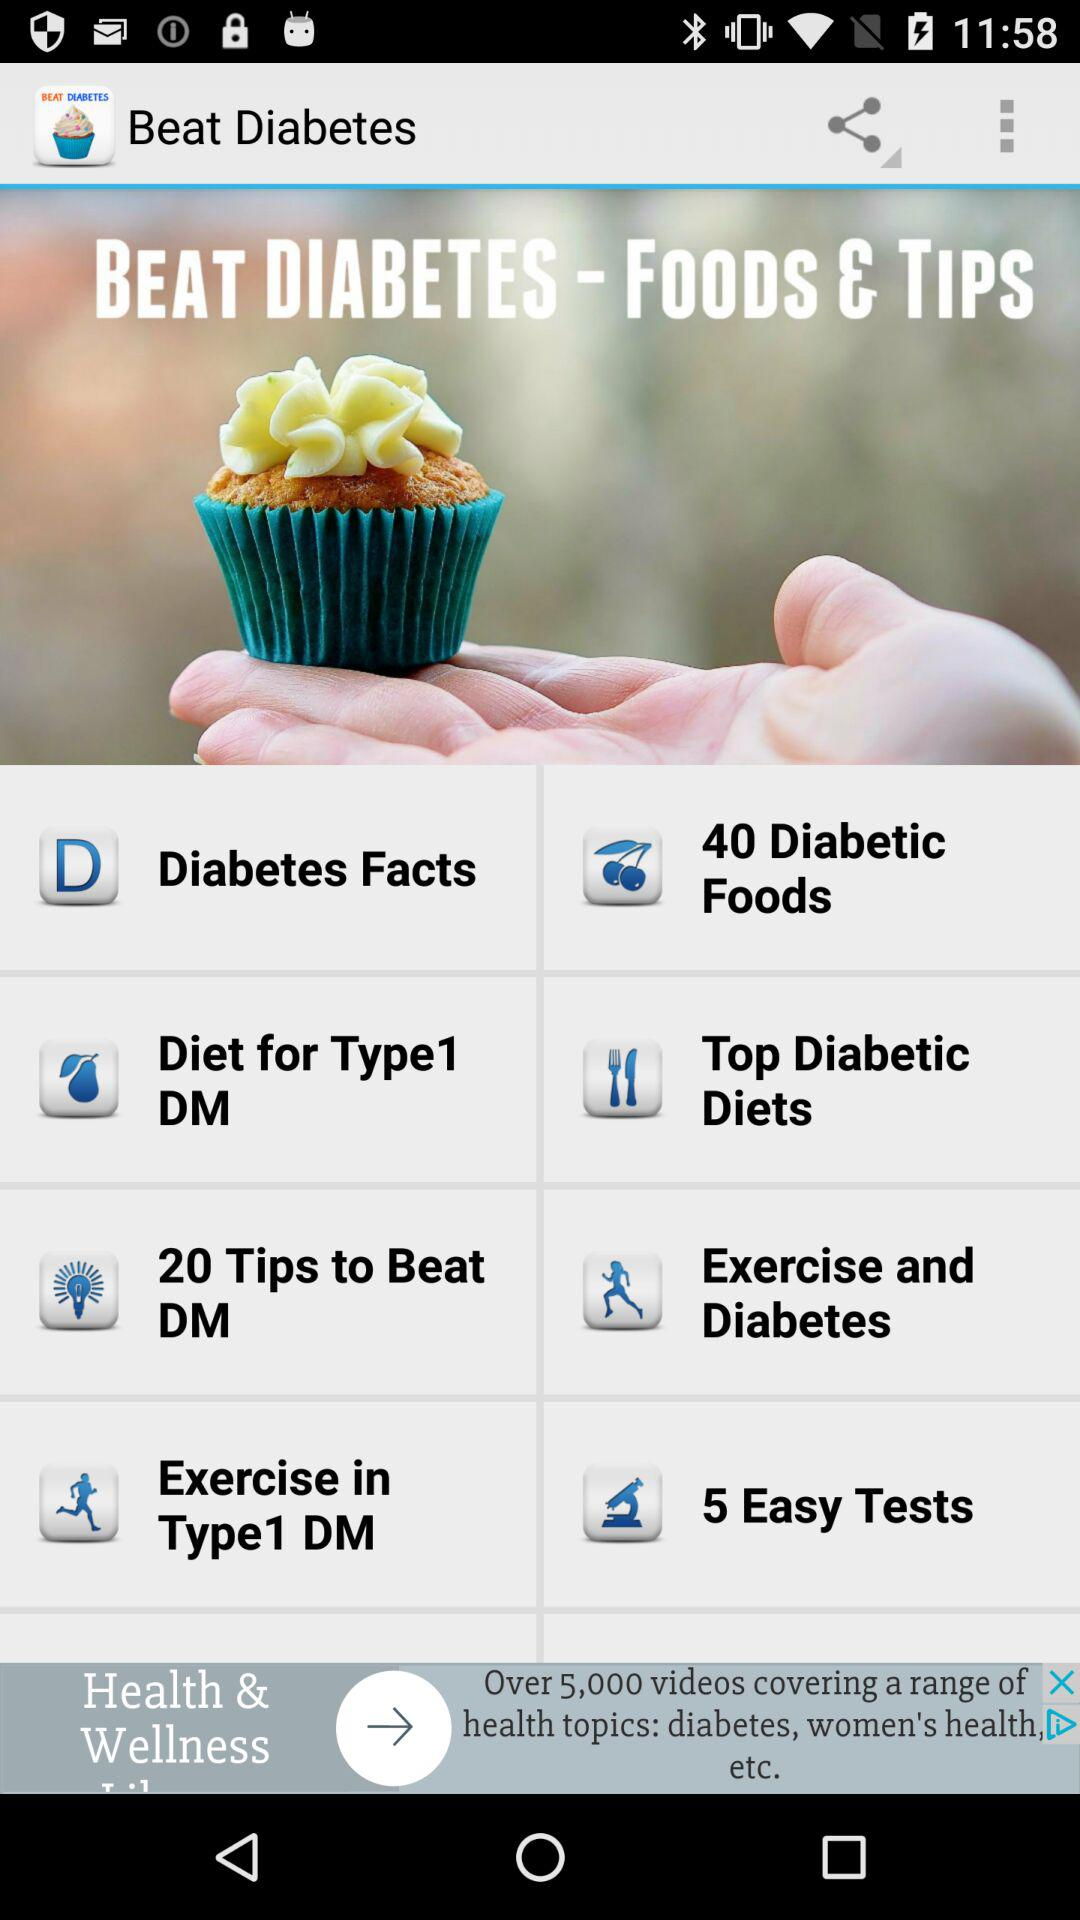What is the application name? The application name is "Beat Diabetes". 